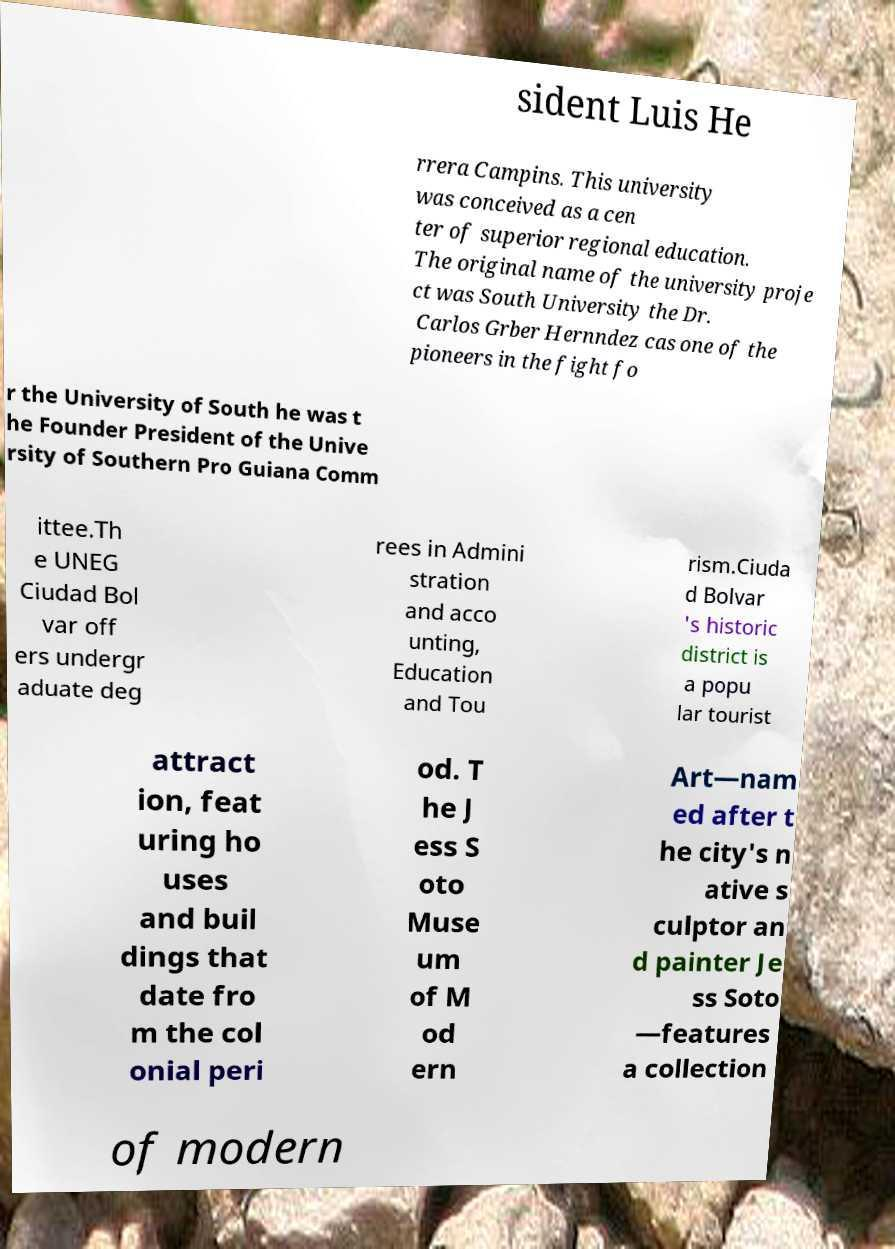I need the written content from this picture converted into text. Can you do that? sident Luis He rrera Campins. This university was conceived as a cen ter of superior regional education. The original name of the university proje ct was South University the Dr. Carlos Grber Hernndez cas one of the pioneers in the fight fo r the University of South he was t he Founder President of the Unive rsity of Southern Pro Guiana Comm ittee.Th e UNEG Ciudad Bol var off ers undergr aduate deg rees in Admini stration and acco unting, Education and Tou rism.Ciuda d Bolvar 's historic district is a popu lar tourist attract ion, feat uring ho uses and buil dings that date fro m the col onial peri od. T he J ess S oto Muse um of M od ern Art—nam ed after t he city's n ative s culptor an d painter Je ss Soto —features a collection of modern 